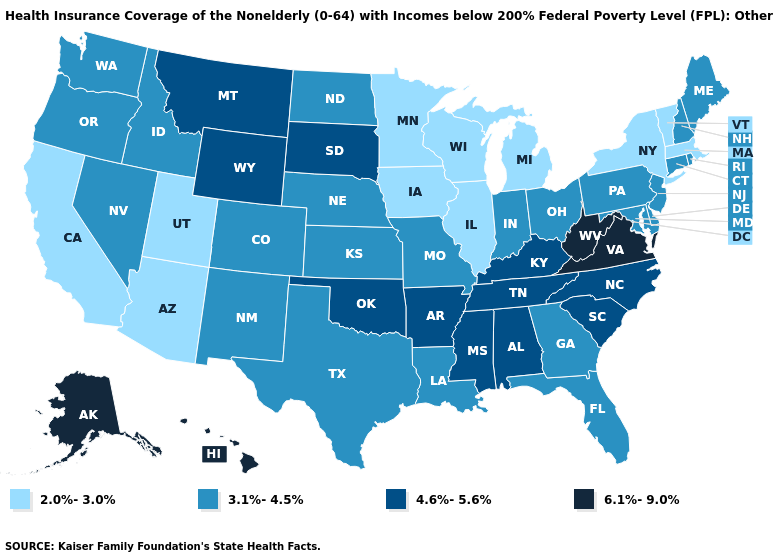Does West Virginia have the highest value in the USA?
Write a very short answer. Yes. Name the states that have a value in the range 6.1%-9.0%?
Concise answer only. Alaska, Hawaii, Virginia, West Virginia. Among the states that border Massachusetts , does Connecticut have the highest value?
Write a very short answer. Yes. Which states hav the highest value in the Northeast?
Write a very short answer. Connecticut, Maine, New Hampshire, New Jersey, Pennsylvania, Rhode Island. Name the states that have a value in the range 4.6%-5.6%?
Be succinct. Alabama, Arkansas, Kentucky, Mississippi, Montana, North Carolina, Oklahoma, South Carolina, South Dakota, Tennessee, Wyoming. What is the highest value in the West ?
Answer briefly. 6.1%-9.0%. What is the highest value in states that border New Jersey?
Keep it brief. 3.1%-4.5%. What is the lowest value in states that border Missouri?
Keep it brief. 2.0%-3.0%. What is the lowest value in the MidWest?
Quick response, please. 2.0%-3.0%. Name the states that have a value in the range 6.1%-9.0%?
Short answer required. Alaska, Hawaii, Virginia, West Virginia. Does Alaska have the highest value in the USA?
Keep it brief. Yes. Name the states that have a value in the range 2.0%-3.0%?
Write a very short answer. Arizona, California, Illinois, Iowa, Massachusetts, Michigan, Minnesota, New York, Utah, Vermont, Wisconsin. What is the value of Nebraska?
Give a very brief answer. 3.1%-4.5%. Does Maine have the lowest value in the Northeast?
Quick response, please. No. What is the highest value in states that border Arkansas?
Answer briefly. 4.6%-5.6%. 